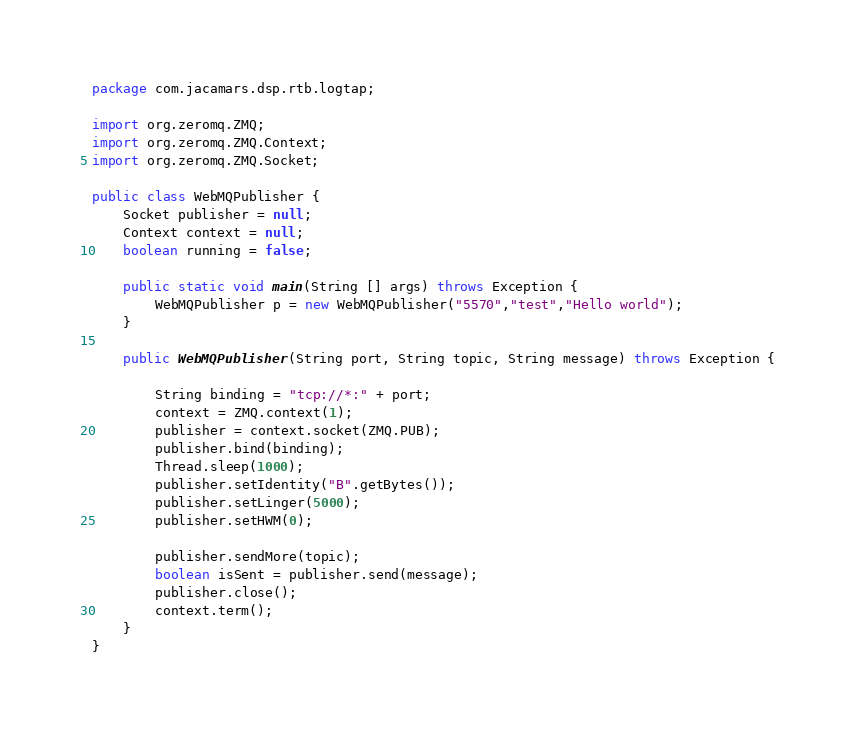Convert code to text. <code><loc_0><loc_0><loc_500><loc_500><_Java_>package com.jacamars.dsp.rtb.logtap;

import org.zeromq.ZMQ;
import org.zeromq.ZMQ.Context;
import org.zeromq.ZMQ.Socket;

public class WebMQPublisher {
	Socket publisher = null;
	Context context = null;
	boolean running = false;
	
	public static void main(String [] args) throws Exception {
		WebMQPublisher p = new WebMQPublisher("5570","test","Hello world");
	}

	public WebMQPublisher(String port, String topic, String message) throws Exception {

		String binding = "tcp://*:" + port;
		context = ZMQ.context(1);
		publisher = context.socket(ZMQ.PUB);
		publisher.bind(binding);
		Thread.sleep(1000);
		publisher.setIdentity("B".getBytes());
		publisher.setLinger(5000);
		publisher.setHWM(0);

		publisher.sendMore(topic);
		boolean isSent = publisher.send(message);
		publisher.close();
		context.term();
	}
}</code> 